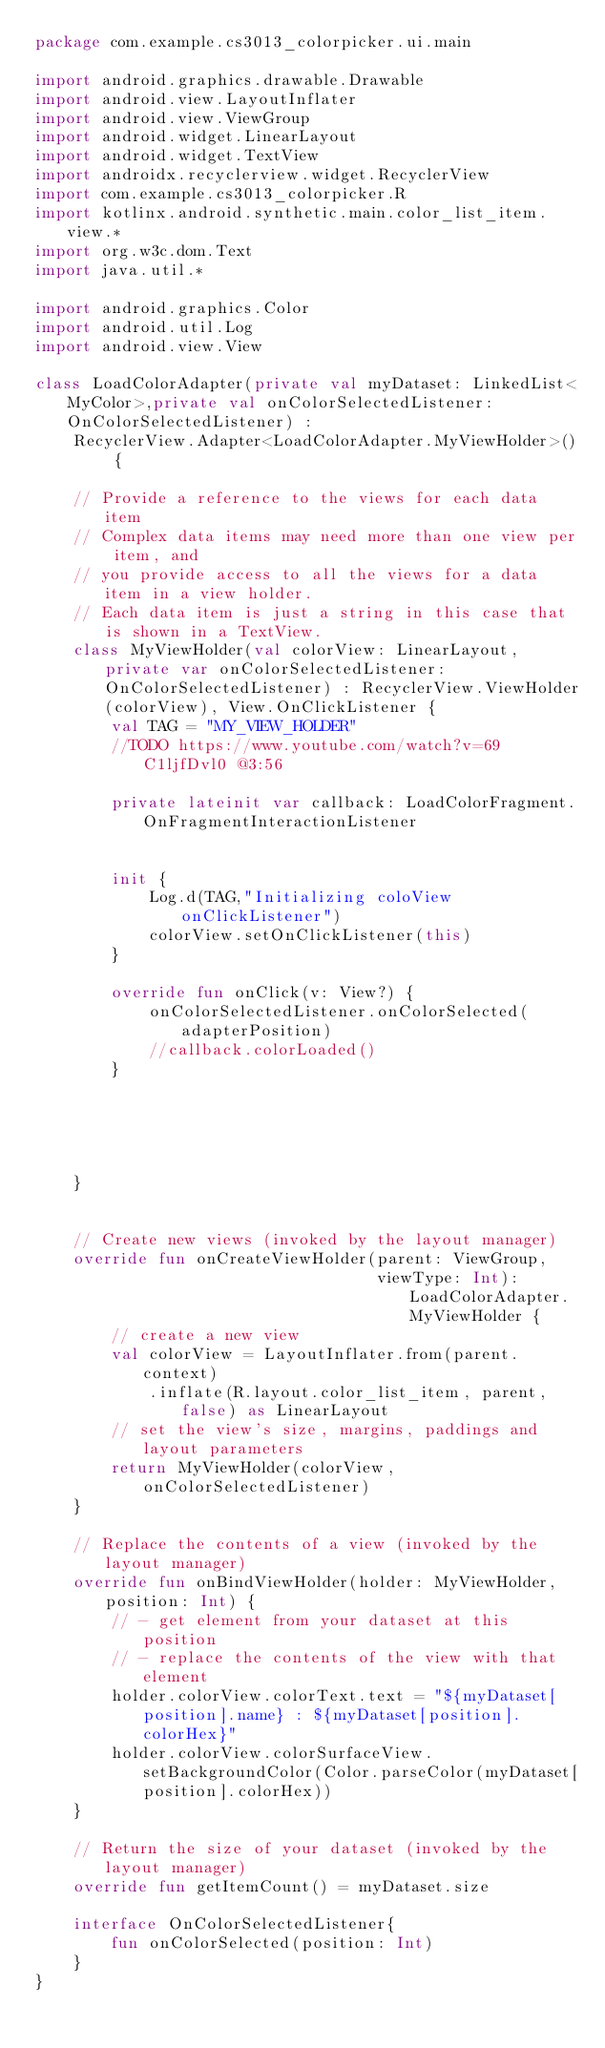<code> <loc_0><loc_0><loc_500><loc_500><_Kotlin_>package com.example.cs3013_colorpicker.ui.main

import android.graphics.drawable.Drawable
import android.view.LayoutInflater
import android.view.ViewGroup
import android.widget.LinearLayout
import android.widget.TextView
import androidx.recyclerview.widget.RecyclerView
import com.example.cs3013_colorpicker.R
import kotlinx.android.synthetic.main.color_list_item.view.*
import org.w3c.dom.Text
import java.util.*

import android.graphics.Color
import android.util.Log
import android.view.View

class LoadColorAdapter(private val myDataset: LinkedList<MyColor>,private val onColorSelectedListener: OnColorSelectedListener) :
    RecyclerView.Adapter<LoadColorAdapter.MyViewHolder>() {

    // Provide a reference to the views for each data item
    // Complex data items may need more than one view per item, and
    // you provide access to all the views for a data item in a view holder.
    // Each data item is just a string in this case that is shown in a TextView.
    class MyViewHolder(val colorView: LinearLayout,private var onColorSelectedListener: OnColorSelectedListener) : RecyclerView.ViewHolder(colorView), View.OnClickListener {
        val TAG = "MY_VIEW_HOLDER"
        //TODO https://www.youtube.com/watch?v=69C1ljfDvl0 @3:56

        private lateinit var callback: LoadColorFragment.OnFragmentInteractionListener


        init {
            Log.d(TAG,"Initializing coloView onClickListener")
            colorView.setOnClickListener(this)
        }

        override fun onClick(v: View?) {
            onColorSelectedListener.onColorSelected(adapterPosition)
            //callback.colorLoaded()
        }





    }


    // Create new views (invoked by the layout manager)
    override fun onCreateViewHolder(parent: ViewGroup,
                                    viewType: Int): LoadColorAdapter.MyViewHolder {
        // create a new view
        val colorView = LayoutInflater.from(parent.context)
            .inflate(R.layout.color_list_item, parent, false) as LinearLayout
        // set the view's size, margins, paddings and layout parameters
        return MyViewHolder(colorView,onColorSelectedListener)
    }

    // Replace the contents of a view (invoked by the layout manager)
    override fun onBindViewHolder(holder: MyViewHolder, position: Int) {
        // - get element from your dataset at this position
        // - replace the contents of the view with that element
        holder.colorView.colorText.text = "${myDataset[position].name} : ${myDataset[position].colorHex}"
        holder.colorView.colorSurfaceView.setBackgroundColor(Color.parseColor(myDataset[position].colorHex))
    }

    // Return the size of your dataset (invoked by the layout manager)
    override fun getItemCount() = myDataset.size

    interface OnColorSelectedListener{
        fun onColorSelected(position: Int)
    }
}</code> 